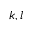<formula> <loc_0><loc_0><loc_500><loc_500>k , l</formula> 